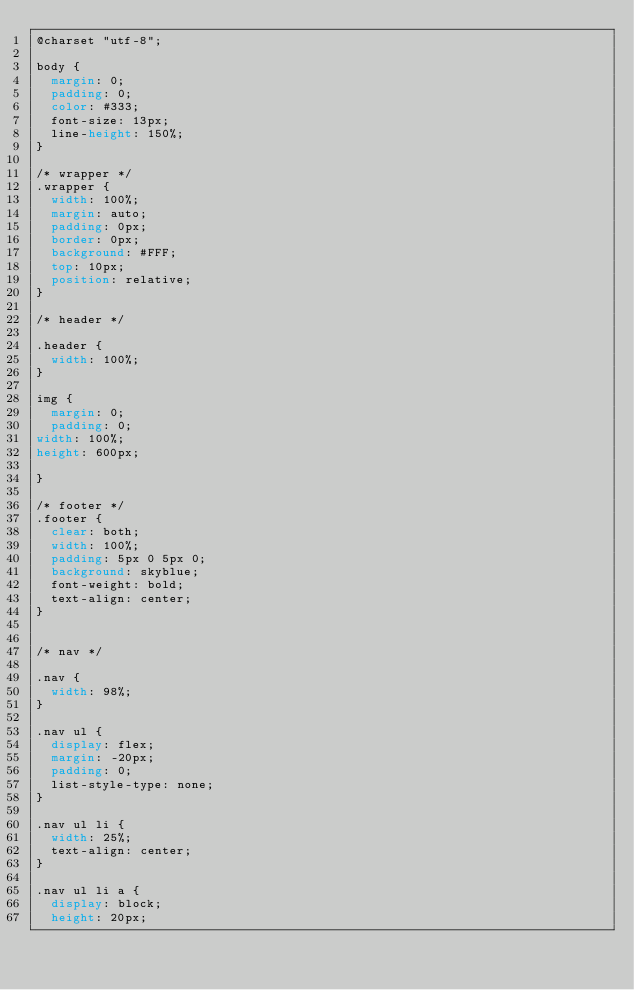Convert code to text. <code><loc_0><loc_0><loc_500><loc_500><_CSS_>@charset "utf-8";

body {
  margin: 0;
  padding: 0;
  color: #333;
  font-size: 13px;
  line-height: 150%;
}

/* wrapper */
.wrapper {
  width: 100%;
  margin: auto;
  padding: 0px;
  border: 0px;
  background: #FFF;
  top: 10px;
  position: relative;
}

/* header */

.header {
  width: 100%;
}

img {
  margin: 0;
  padding: 0;
width: 100%;
height: 600px;

}

/* footer */
.footer {
  clear: both;
  width: 100%;
  padding: 5px 0 5px 0;
  background: skyblue;
  font-weight: bold;
  text-align: center;
}


/* nav */

.nav {
  width: 98%;
}

.nav ul {
  display: flex;
  margin: -20px;
  padding: 0;
  list-style-type: none;
}

.nav ul li {
  width: 25%;
  text-align: center;
}

.nav ul li a {
  display: block;
  height: 20px;</code> 